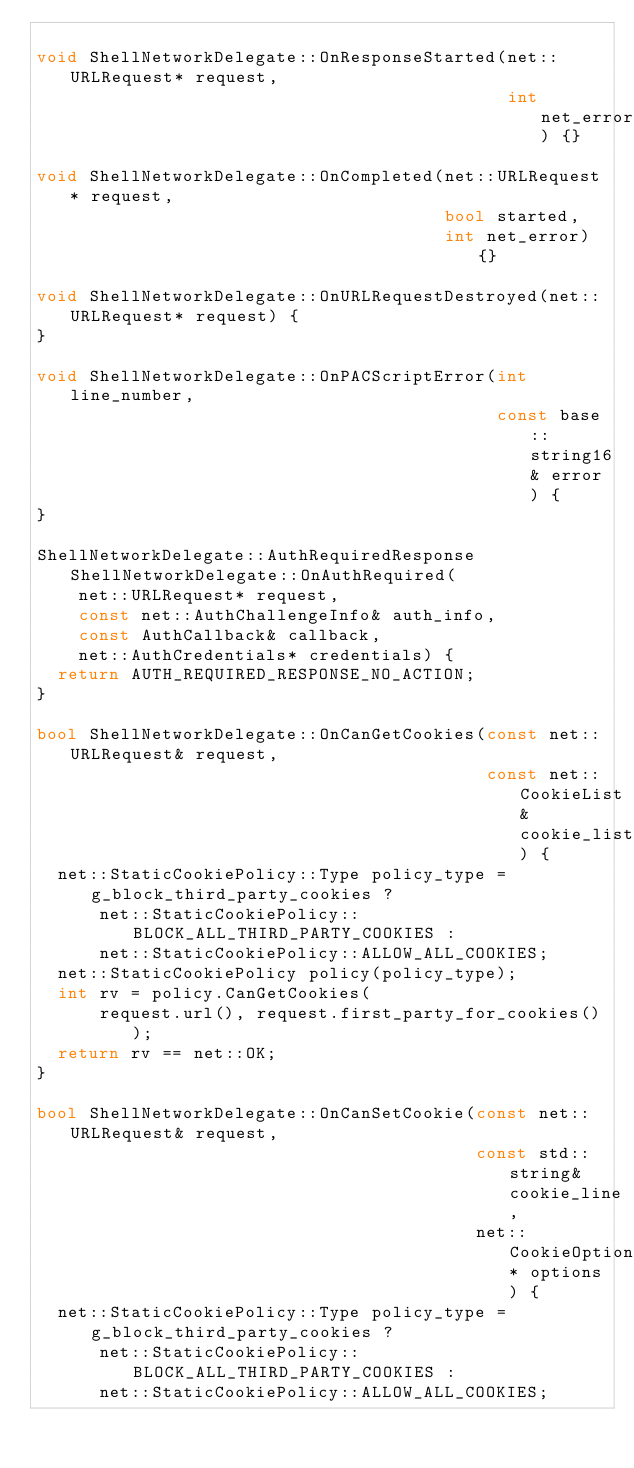<code> <loc_0><loc_0><loc_500><loc_500><_C++_>
void ShellNetworkDelegate::OnResponseStarted(net::URLRequest* request,
                                             int net_error) {}

void ShellNetworkDelegate::OnCompleted(net::URLRequest* request,
                                       bool started,
                                       int net_error) {}

void ShellNetworkDelegate::OnURLRequestDestroyed(net::URLRequest* request) {
}

void ShellNetworkDelegate::OnPACScriptError(int line_number,
                                            const base::string16& error) {
}

ShellNetworkDelegate::AuthRequiredResponse ShellNetworkDelegate::OnAuthRequired(
    net::URLRequest* request,
    const net::AuthChallengeInfo& auth_info,
    const AuthCallback& callback,
    net::AuthCredentials* credentials) {
  return AUTH_REQUIRED_RESPONSE_NO_ACTION;
}

bool ShellNetworkDelegate::OnCanGetCookies(const net::URLRequest& request,
                                           const net::CookieList& cookie_list) {
  net::StaticCookiePolicy::Type policy_type = g_block_third_party_cookies ?
      net::StaticCookiePolicy::BLOCK_ALL_THIRD_PARTY_COOKIES :
      net::StaticCookiePolicy::ALLOW_ALL_COOKIES;
  net::StaticCookiePolicy policy(policy_type);
  int rv = policy.CanGetCookies(
      request.url(), request.first_party_for_cookies());
  return rv == net::OK;
}

bool ShellNetworkDelegate::OnCanSetCookie(const net::URLRequest& request,
                                          const std::string& cookie_line,
                                          net::CookieOptions* options) {
  net::StaticCookiePolicy::Type policy_type = g_block_third_party_cookies ?
      net::StaticCookiePolicy::BLOCK_ALL_THIRD_PARTY_COOKIES :
      net::StaticCookiePolicy::ALLOW_ALL_COOKIES;</code> 